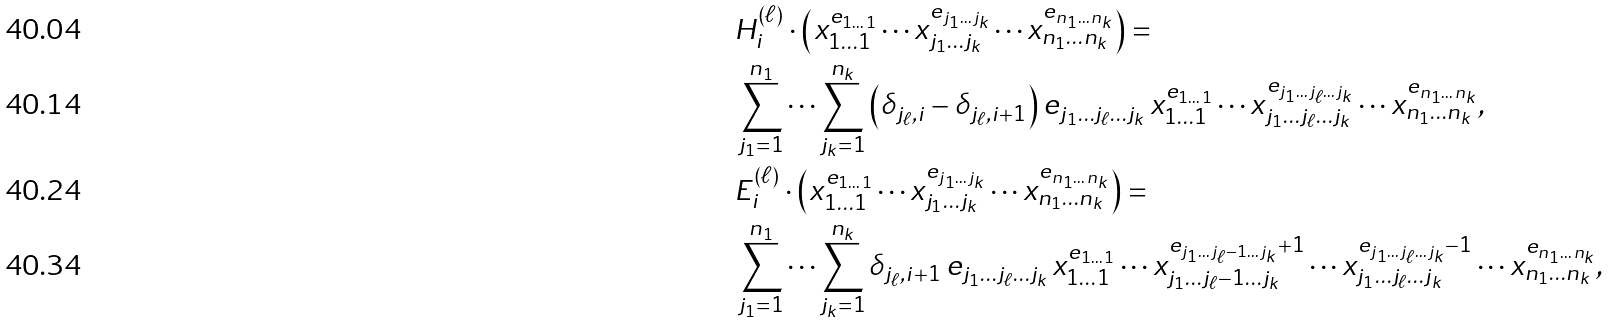Convert formula to latex. <formula><loc_0><loc_0><loc_500><loc_500>& H ^ { ( \ell ) } _ { i } \cdot \left ( x _ { 1 \dots 1 } ^ { e _ { 1 \dots 1 } } \cdots x _ { j _ { 1 } \dots j _ { k } } ^ { e _ { j _ { 1 } \dots j _ { k } } } \cdots x _ { n _ { 1 } \dots n _ { k } } ^ { e _ { n _ { 1 } \dots n _ { k } } } \right ) = \\ & \sum _ { j _ { 1 } = 1 } ^ { n _ { 1 } } \cdots \sum _ { j _ { k } = 1 } ^ { n _ { k } } \left ( \delta _ { j _ { \ell } , i } - \delta _ { j _ { \ell } , i + 1 } \right ) e _ { j _ { 1 } \dots j _ { \ell } \dots j _ { k } } \, x _ { 1 \dots 1 } ^ { e _ { 1 \dots 1 } } \cdots x _ { j _ { 1 } \dots j _ { \ell } \dots j _ { k } } ^ { e _ { j _ { 1 } \dots j _ { \ell } \dots j _ { k } } } \cdots x _ { n _ { 1 } \dots n _ { k } } ^ { e _ { n _ { 1 } \dots n _ { k } } } , \\ & E ^ { ( \ell ) } _ { i } \cdot \left ( x _ { 1 \dots 1 } ^ { e _ { 1 \dots 1 } } \cdots x _ { j _ { 1 } \dots j _ { k } } ^ { e _ { j _ { 1 } \dots j _ { k } } } \cdots x _ { n _ { 1 } \dots n _ { k } } ^ { e _ { n _ { 1 } \dots n _ { k } } } \right ) = \\ & \sum _ { j _ { 1 } = 1 } ^ { n _ { 1 } } \cdots \sum _ { j _ { k } = 1 } ^ { n _ { k } } \delta _ { j _ { \ell } , i + 1 } \, e _ { j _ { 1 } \dots j _ { \ell } \dots j _ { k } } \, x _ { 1 \dots 1 } ^ { e _ { 1 \dots 1 } } \cdots x _ { j _ { 1 } \dots j _ { \ell } - 1 \dots j _ { k } } ^ { e _ { j _ { 1 } \dots j _ { \ell } - 1 \dots j _ { k } } + 1 } \cdots x _ { j _ { 1 } \dots j _ { \ell } \dots j _ { k } } ^ { e _ { j _ { 1 } \dots j _ { \ell } \dots j _ { k } } - 1 } \cdots x _ { n _ { 1 } \dots n _ { k } } ^ { e _ { n _ { 1 } \dots n _ { k } } } ,</formula> 